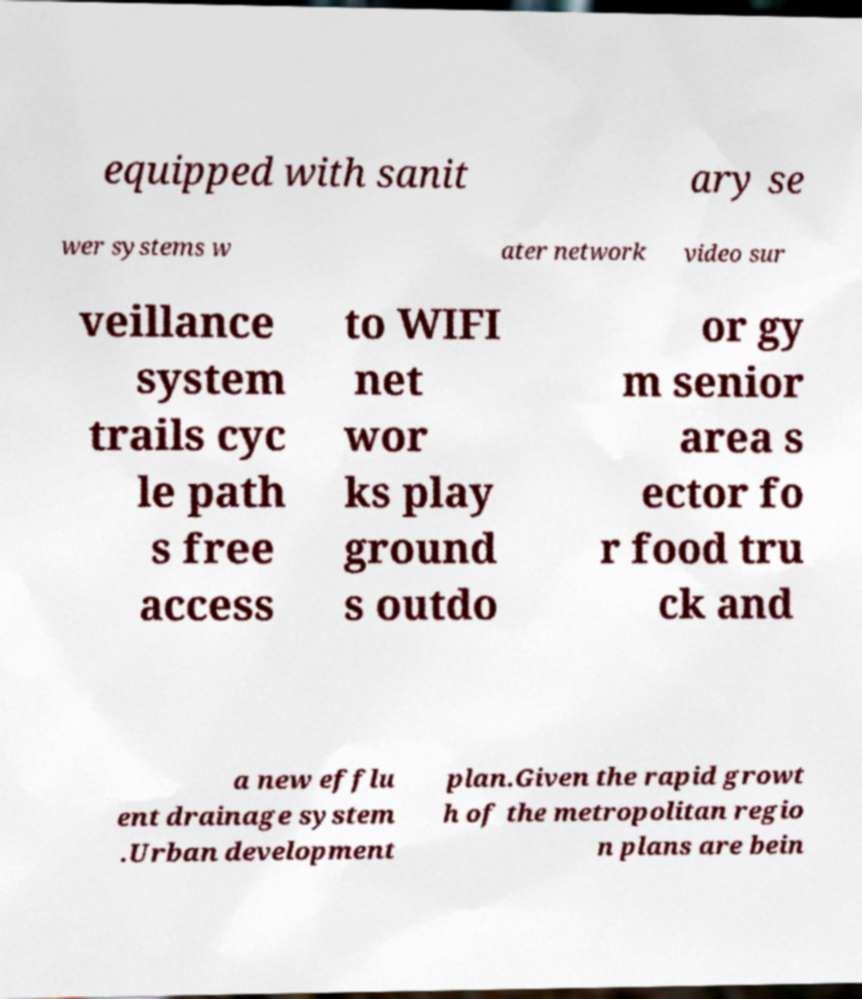Could you extract and type out the text from this image? equipped with sanit ary se wer systems w ater network video sur veillance system trails cyc le path s free access to WIFI net wor ks play ground s outdo or gy m senior area s ector fo r food tru ck and a new efflu ent drainage system .Urban development plan.Given the rapid growt h of the metropolitan regio n plans are bein 